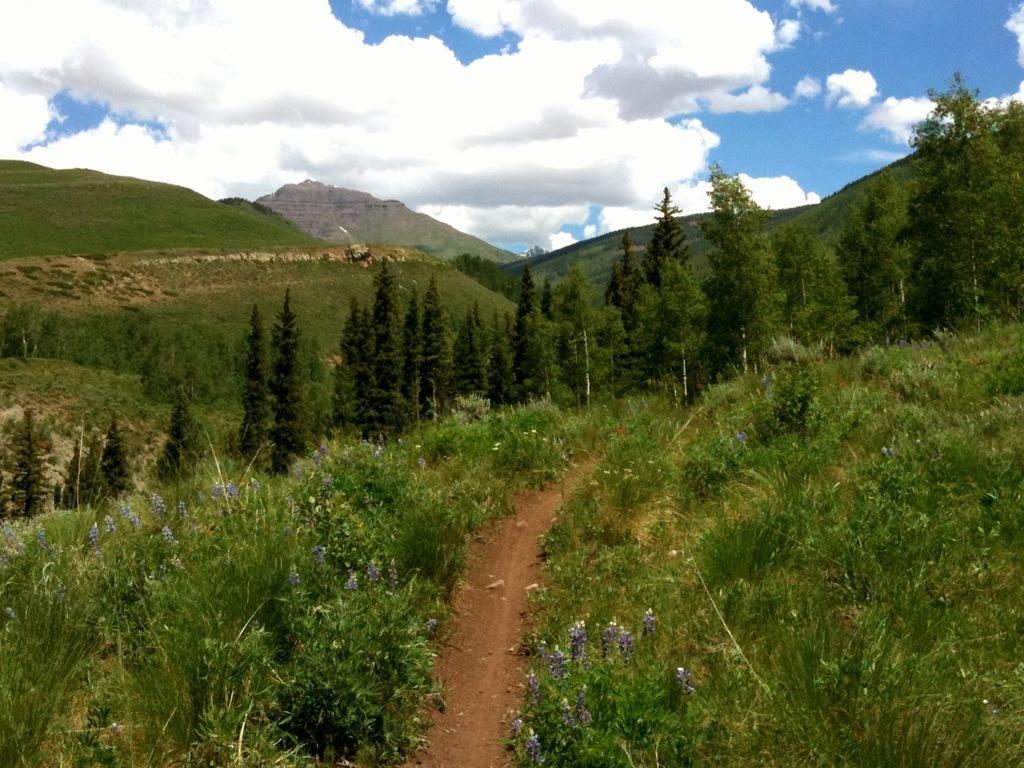In one or two sentences, can you explain what this image depicts? In this picture I can see green grass. I can see trees. I can see the hill. I can see clouds in the sky. 